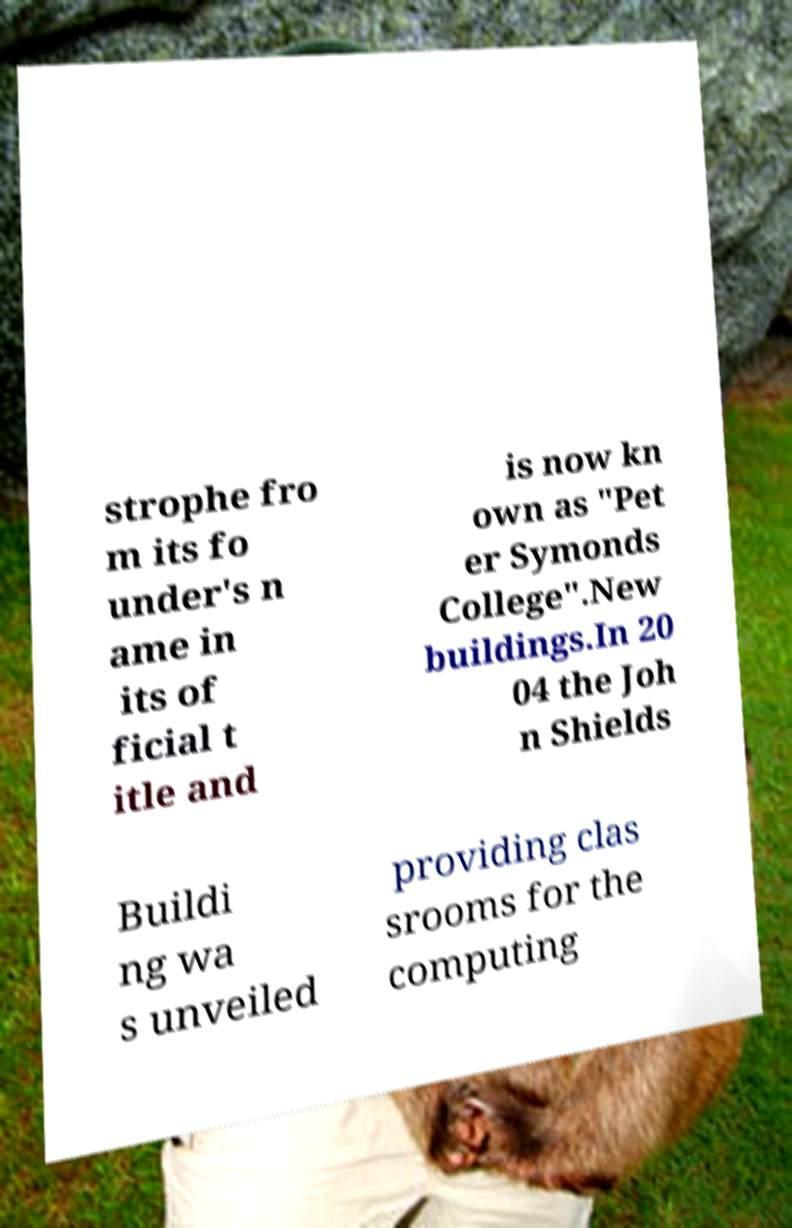Please identify and transcribe the text found in this image. strophe fro m its fo under's n ame in its of ficial t itle and is now kn own as "Pet er Symonds College".New buildings.In 20 04 the Joh n Shields Buildi ng wa s unveiled providing clas srooms for the computing 